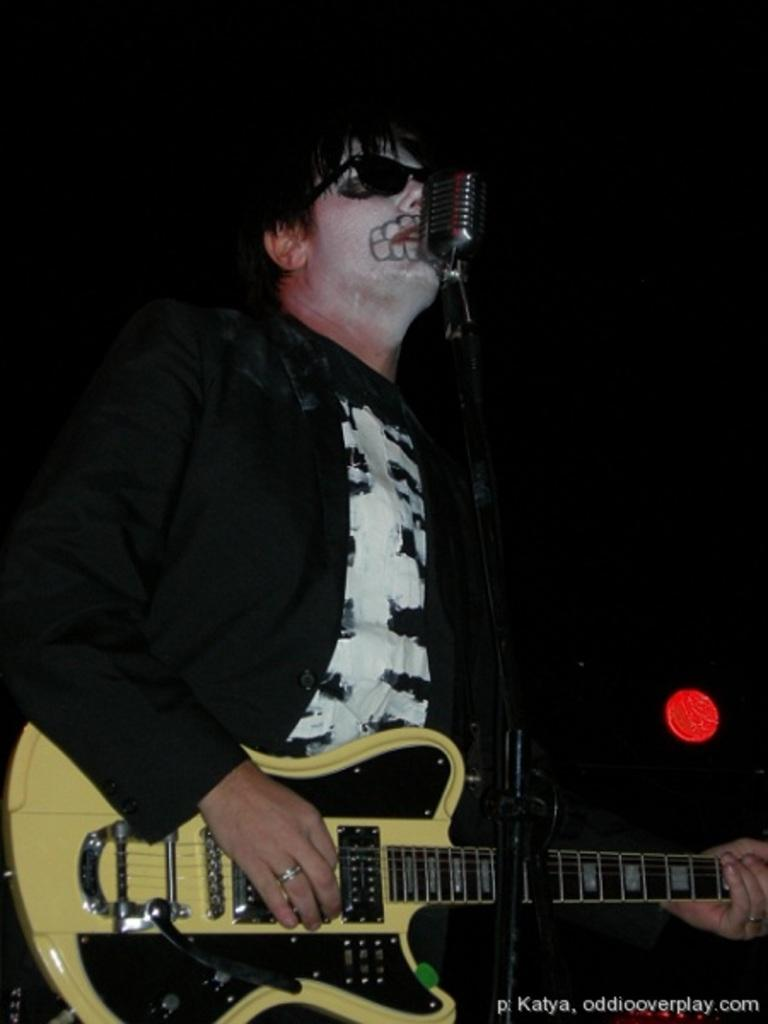What is the overall color scheme of the image? The background of the image is dark. What is the man in the image doing? The man is standing in front of a microphone and playing a guitar. What accessory is the man wearing? The man is wearing black-colored goggles. Can you describe any light source in the image? Yes, there is a light visible in the image. What type of sign can be seen in the yard in the image? There is no sign or yard present in the image; it features a man playing a guitar in front of a microphone. What type of furniture is visible in the image? There is no furniture visible in the image. 